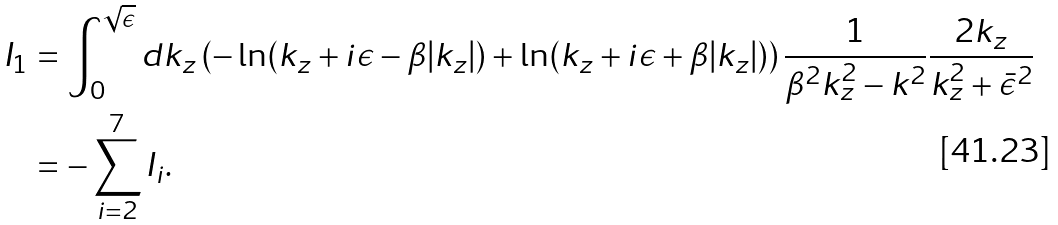Convert formula to latex. <formula><loc_0><loc_0><loc_500><loc_500>I _ { 1 } & = \int _ { 0 } ^ { \sqrt { \epsilon } } d k _ { z } \left ( - \ln ( k _ { z } + i \epsilon - \beta | k _ { z } | ) + \ln ( k _ { z } + i \epsilon + \beta | k _ { z } | ) \right ) \frac { 1 } { \beta ^ { 2 } k _ { z } ^ { 2 } - { k } ^ { 2 } } \frac { 2 k _ { z } } { k _ { z } ^ { 2 } + \bar { \epsilon } ^ { 2 } } \\ & = - \sum _ { i = 2 } ^ { 7 } I _ { i } .</formula> 